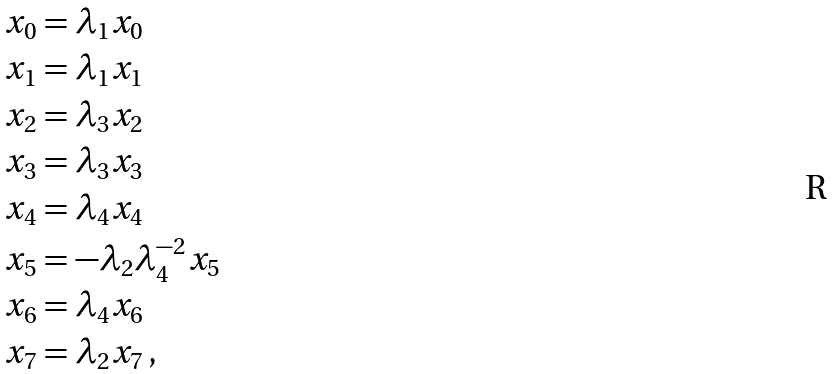<formula> <loc_0><loc_0><loc_500><loc_500>x _ { 0 } & = \lambda _ { 1 } x _ { 0 } \\ x _ { 1 } & = \lambda _ { 1 } x _ { 1 } \\ x _ { 2 } & = \lambda _ { 3 } x _ { 2 } \\ x _ { 3 } & = \lambda _ { 3 } x _ { 3 } \\ x _ { 4 } & = \lambda _ { 4 } x _ { 4 } \\ x _ { 5 } & = - \lambda _ { 2 } \lambda _ { 4 } ^ { - 2 } x _ { 5 } \\ x _ { 6 } & = \lambda _ { 4 } x _ { 6 } \\ x _ { 7 } & = \lambda _ { 2 } x _ { 7 } \, ,</formula> 